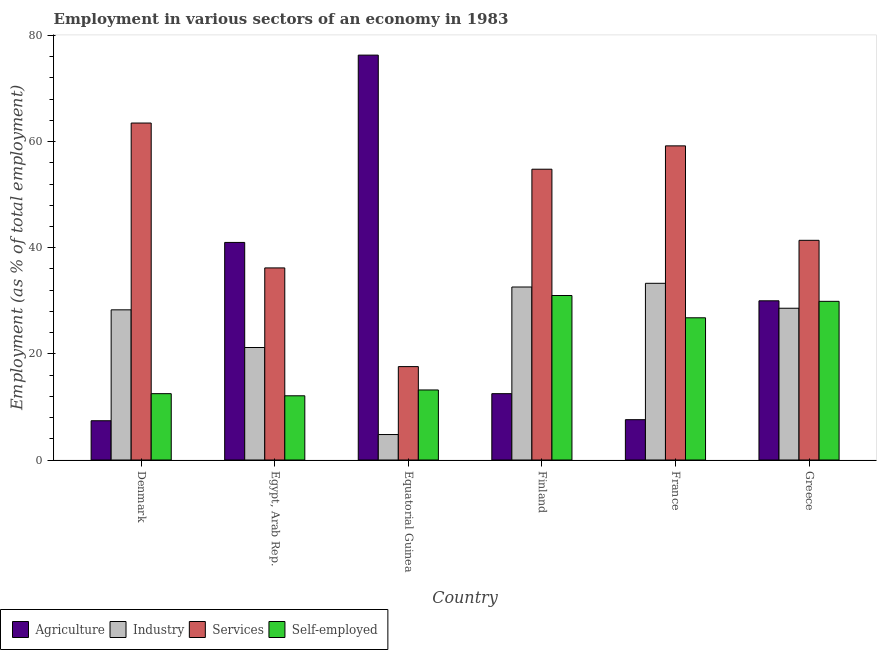Are the number of bars per tick equal to the number of legend labels?
Offer a very short reply. Yes. What is the percentage of workers in industry in France?
Your response must be concise. 33.3. Across all countries, what is the maximum percentage of workers in services?
Keep it short and to the point. 63.5. Across all countries, what is the minimum percentage of workers in services?
Your answer should be very brief. 17.6. In which country was the percentage of workers in services minimum?
Offer a terse response. Equatorial Guinea. What is the total percentage of workers in industry in the graph?
Keep it short and to the point. 148.8. What is the difference between the percentage of workers in agriculture in Equatorial Guinea and that in Greece?
Your answer should be very brief. 46.3. What is the difference between the percentage of workers in industry in Denmark and the percentage of self employed workers in Greece?
Provide a succinct answer. -1.6. What is the average percentage of workers in services per country?
Your answer should be compact. 45.45. What is the difference between the percentage of workers in agriculture and percentage of self employed workers in Equatorial Guinea?
Give a very brief answer. 63.1. What is the ratio of the percentage of workers in services in Denmark to that in Finland?
Your answer should be very brief. 1.16. Is the difference between the percentage of workers in services in Denmark and Finland greater than the difference between the percentage of workers in industry in Denmark and Finland?
Provide a short and direct response. Yes. What is the difference between the highest and the second highest percentage of self employed workers?
Provide a succinct answer. 1.1. What is the difference between the highest and the lowest percentage of workers in agriculture?
Make the answer very short. 68.9. Is it the case that in every country, the sum of the percentage of workers in industry and percentage of workers in agriculture is greater than the sum of percentage of self employed workers and percentage of workers in services?
Make the answer very short. No. What does the 3rd bar from the left in France represents?
Provide a short and direct response. Services. What does the 3rd bar from the right in France represents?
Give a very brief answer. Industry. Is it the case that in every country, the sum of the percentage of workers in agriculture and percentage of workers in industry is greater than the percentage of workers in services?
Keep it short and to the point. No. Are all the bars in the graph horizontal?
Ensure brevity in your answer.  No. Are the values on the major ticks of Y-axis written in scientific E-notation?
Provide a short and direct response. No. Does the graph contain any zero values?
Your answer should be very brief. No. How many legend labels are there?
Ensure brevity in your answer.  4. How are the legend labels stacked?
Provide a succinct answer. Horizontal. What is the title of the graph?
Give a very brief answer. Employment in various sectors of an economy in 1983. Does "Debt policy" appear as one of the legend labels in the graph?
Provide a short and direct response. No. What is the label or title of the Y-axis?
Make the answer very short. Employment (as % of total employment). What is the Employment (as % of total employment) in Agriculture in Denmark?
Provide a succinct answer. 7.4. What is the Employment (as % of total employment) of Industry in Denmark?
Give a very brief answer. 28.3. What is the Employment (as % of total employment) in Services in Denmark?
Make the answer very short. 63.5. What is the Employment (as % of total employment) of Industry in Egypt, Arab Rep.?
Offer a very short reply. 21.2. What is the Employment (as % of total employment) in Services in Egypt, Arab Rep.?
Keep it short and to the point. 36.2. What is the Employment (as % of total employment) of Self-employed in Egypt, Arab Rep.?
Make the answer very short. 12.1. What is the Employment (as % of total employment) of Agriculture in Equatorial Guinea?
Give a very brief answer. 76.3. What is the Employment (as % of total employment) of Industry in Equatorial Guinea?
Make the answer very short. 4.8. What is the Employment (as % of total employment) in Services in Equatorial Guinea?
Your response must be concise. 17.6. What is the Employment (as % of total employment) in Self-employed in Equatorial Guinea?
Offer a very short reply. 13.2. What is the Employment (as % of total employment) of Agriculture in Finland?
Your answer should be compact. 12.5. What is the Employment (as % of total employment) of Industry in Finland?
Your response must be concise. 32.6. What is the Employment (as % of total employment) in Services in Finland?
Your answer should be compact. 54.8. What is the Employment (as % of total employment) of Agriculture in France?
Your answer should be very brief. 7.6. What is the Employment (as % of total employment) of Industry in France?
Provide a short and direct response. 33.3. What is the Employment (as % of total employment) of Services in France?
Provide a short and direct response. 59.2. What is the Employment (as % of total employment) in Self-employed in France?
Offer a very short reply. 26.8. What is the Employment (as % of total employment) of Industry in Greece?
Offer a very short reply. 28.6. What is the Employment (as % of total employment) of Services in Greece?
Provide a succinct answer. 41.4. What is the Employment (as % of total employment) of Self-employed in Greece?
Offer a terse response. 29.9. Across all countries, what is the maximum Employment (as % of total employment) in Agriculture?
Offer a very short reply. 76.3. Across all countries, what is the maximum Employment (as % of total employment) of Industry?
Ensure brevity in your answer.  33.3. Across all countries, what is the maximum Employment (as % of total employment) in Services?
Provide a short and direct response. 63.5. Across all countries, what is the maximum Employment (as % of total employment) in Self-employed?
Ensure brevity in your answer.  31. Across all countries, what is the minimum Employment (as % of total employment) in Agriculture?
Offer a terse response. 7.4. Across all countries, what is the minimum Employment (as % of total employment) of Industry?
Provide a succinct answer. 4.8. Across all countries, what is the minimum Employment (as % of total employment) of Services?
Provide a succinct answer. 17.6. Across all countries, what is the minimum Employment (as % of total employment) of Self-employed?
Your answer should be very brief. 12.1. What is the total Employment (as % of total employment) in Agriculture in the graph?
Provide a short and direct response. 174.8. What is the total Employment (as % of total employment) in Industry in the graph?
Keep it short and to the point. 148.8. What is the total Employment (as % of total employment) in Services in the graph?
Provide a short and direct response. 272.7. What is the total Employment (as % of total employment) in Self-employed in the graph?
Offer a terse response. 125.5. What is the difference between the Employment (as % of total employment) of Agriculture in Denmark and that in Egypt, Arab Rep.?
Your answer should be very brief. -33.6. What is the difference between the Employment (as % of total employment) in Services in Denmark and that in Egypt, Arab Rep.?
Provide a short and direct response. 27.3. What is the difference between the Employment (as % of total employment) in Agriculture in Denmark and that in Equatorial Guinea?
Provide a short and direct response. -68.9. What is the difference between the Employment (as % of total employment) in Industry in Denmark and that in Equatorial Guinea?
Your response must be concise. 23.5. What is the difference between the Employment (as % of total employment) of Services in Denmark and that in Equatorial Guinea?
Make the answer very short. 45.9. What is the difference between the Employment (as % of total employment) of Self-employed in Denmark and that in Finland?
Make the answer very short. -18.5. What is the difference between the Employment (as % of total employment) in Agriculture in Denmark and that in France?
Provide a short and direct response. -0.2. What is the difference between the Employment (as % of total employment) of Self-employed in Denmark and that in France?
Offer a very short reply. -14.3. What is the difference between the Employment (as % of total employment) in Agriculture in Denmark and that in Greece?
Provide a short and direct response. -22.6. What is the difference between the Employment (as % of total employment) of Services in Denmark and that in Greece?
Your response must be concise. 22.1. What is the difference between the Employment (as % of total employment) of Self-employed in Denmark and that in Greece?
Your answer should be very brief. -17.4. What is the difference between the Employment (as % of total employment) of Agriculture in Egypt, Arab Rep. and that in Equatorial Guinea?
Keep it short and to the point. -35.3. What is the difference between the Employment (as % of total employment) of Industry in Egypt, Arab Rep. and that in Equatorial Guinea?
Offer a terse response. 16.4. What is the difference between the Employment (as % of total employment) in Services in Egypt, Arab Rep. and that in Equatorial Guinea?
Your response must be concise. 18.6. What is the difference between the Employment (as % of total employment) in Self-employed in Egypt, Arab Rep. and that in Equatorial Guinea?
Give a very brief answer. -1.1. What is the difference between the Employment (as % of total employment) of Industry in Egypt, Arab Rep. and that in Finland?
Give a very brief answer. -11.4. What is the difference between the Employment (as % of total employment) of Services in Egypt, Arab Rep. and that in Finland?
Make the answer very short. -18.6. What is the difference between the Employment (as % of total employment) of Self-employed in Egypt, Arab Rep. and that in Finland?
Offer a very short reply. -18.9. What is the difference between the Employment (as % of total employment) of Agriculture in Egypt, Arab Rep. and that in France?
Provide a succinct answer. 33.4. What is the difference between the Employment (as % of total employment) in Services in Egypt, Arab Rep. and that in France?
Give a very brief answer. -23. What is the difference between the Employment (as % of total employment) in Self-employed in Egypt, Arab Rep. and that in France?
Give a very brief answer. -14.7. What is the difference between the Employment (as % of total employment) in Services in Egypt, Arab Rep. and that in Greece?
Your answer should be very brief. -5.2. What is the difference between the Employment (as % of total employment) of Self-employed in Egypt, Arab Rep. and that in Greece?
Make the answer very short. -17.8. What is the difference between the Employment (as % of total employment) of Agriculture in Equatorial Guinea and that in Finland?
Make the answer very short. 63.8. What is the difference between the Employment (as % of total employment) in Industry in Equatorial Guinea and that in Finland?
Your response must be concise. -27.8. What is the difference between the Employment (as % of total employment) of Services in Equatorial Guinea and that in Finland?
Provide a short and direct response. -37.2. What is the difference between the Employment (as % of total employment) in Self-employed in Equatorial Guinea and that in Finland?
Make the answer very short. -17.8. What is the difference between the Employment (as % of total employment) of Agriculture in Equatorial Guinea and that in France?
Your answer should be very brief. 68.7. What is the difference between the Employment (as % of total employment) in Industry in Equatorial Guinea and that in France?
Offer a very short reply. -28.5. What is the difference between the Employment (as % of total employment) of Services in Equatorial Guinea and that in France?
Your response must be concise. -41.6. What is the difference between the Employment (as % of total employment) in Agriculture in Equatorial Guinea and that in Greece?
Your answer should be very brief. 46.3. What is the difference between the Employment (as % of total employment) of Industry in Equatorial Guinea and that in Greece?
Your response must be concise. -23.8. What is the difference between the Employment (as % of total employment) of Services in Equatorial Guinea and that in Greece?
Your answer should be very brief. -23.8. What is the difference between the Employment (as % of total employment) of Self-employed in Equatorial Guinea and that in Greece?
Offer a very short reply. -16.7. What is the difference between the Employment (as % of total employment) of Industry in Finland and that in France?
Offer a very short reply. -0.7. What is the difference between the Employment (as % of total employment) of Agriculture in Finland and that in Greece?
Provide a short and direct response. -17.5. What is the difference between the Employment (as % of total employment) in Agriculture in France and that in Greece?
Offer a terse response. -22.4. What is the difference between the Employment (as % of total employment) in Services in France and that in Greece?
Provide a succinct answer. 17.8. What is the difference between the Employment (as % of total employment) in Self-employed in France and that in Greece?
Make the answer very short. -3.1. What is the difference between the Employment (as % of total employment) of Agriculture in Denmark and the Employment (as % of total employment) of Services in Egypt, Arab Rep.?
Give a very brief answer. -28.8. What is the difference between the Employment (as % of total employment) in Industry in Denmark and the Employment (as % of total employment) in Services in Egypt, Arab Rep.?
Your answer should be compact. -7.9. What is the difference between the Employment (as % of total employment) in Services in Denmark and the Employment (as % of total employment) in Self-employed in Egypt, Arab Rep.?
Keep it short and to the point. 51.4. What is the difference between the Employment (as % of total employment) in Agriculture in Denmark and the Employment (as % of total employment) in Industry in Equatorial Guinea?
Provide a short and direct response. 2.6. What is the difference between the Employment (as % of total employment) of Agriculture in Denmark and the Employment (as % of total employment) of Services in Equatorial Guinea?
Provide a short and direct response. -10.2. What is the difference between the Employment (as % of total employment) in Industry in Denmark and the Employment (as % of total employment) in Self-employed in Equatorial Guinea?
Offer a very short reply. 15.1. What is the difference between the Employment (as % of total employment) in Services in Denmark and the Employment (as % of total employment) in Self-employed in Equatorial Guinea?
Provide a short and direct response. 50.3. What is the difference between the Employment (as % of total employment) of Agriculture in Denmark and the Employment (as % of total employment) of Industry in Finland?
Provide a short and direct response. -25.2. What is the difference between the Employment (as % of total employment) in Agriculture in Denmark and the Employment (as % of total employment) in Services in Finland?
Offer a terse response. -47.4. What is the difference between the Employment (as % of total employment) of Agriculture in Denmark and the Employment (as % of total employment) of Self-employed in Finland?
Offer a very short reply. -23.6. What is the difference between the Employment (as % of total employment) in Industry in Denmark and the Employment (as % of total employment) in Services in Finland?
Offer a terse response. -26.5. What is the difference between the Employment (as % of total employment) in Services in Denmark and the Employment (as % of total employment) in Self-employed in Finland?
Provide a short and direct response. 32.5. What is the difference between the Employment (as % of total employment) of Agriculture in Denmark and the Employment (as % of total employment) of Industry in France?
Your answer should be very brief. -25.9. What is the difference between the Employment (as % of total employment) of Agriculture in Denmark and the Employment (as % of total employment) of Services in France?
Provide a short and direct response. -51.8. What is the difference between the Employment (as % of total employment) in Agriculture in Denmark and the Employment (as % of total employment) in Self-employed in France?
Keep it short and to the point. -19.4. What is the difference between the Employment (as % of total employment) in Industry in Denmark and the Employment (as % of total employment) in Services in France?
Make the answer very short. -30.9. What is the difference between the Employment (as % of total employment) of Services in Denmark and the Employment (as % of total employment) of Self-employed in France?
Your answer should be compact. 36.7. What is the difference between the Employment (as % of total employment) in Agriculture in Denmark and the Employment (as % of total employment) in Industry in Greece?
Your answer should be compact. -21.2. What is the difference between the Employment (as % of total employment) of Agriculture in Denmark and the Employment (as % of total employment) of Services in Greece?
Ensure brevity in your answer.  -34. What is the difference between the Employment (as % of total employment) of Agriculture in Denmark and the Employment (as % of total employment) of Self-employed in Greece?
Your answer should be compact. -22.5. What is the difference between the Employment (as % of total employment) in Services in Denmark and the Employment (as % of total employment) in Self-employed in Greece?
Your response must be concise. 33.6. What is the difference between the Employment (as % of total employment) in Agriculture in Egypt, Arab Rep. and the Employment (as % of total employment) in Industry in Equatorial Guinea?
Give a very brief answer. 36.2. What is the difference between the Employment (as % of total employment) in Agriculture in Egypt, Arab Rep. and the Employment (as % of total employment) in Services in Equatorial Guinea?
Provide a succinct answer. 23.4. What is the difference between the Employment (as % of total employment) in Agriculture in Egypt, Arab Rep. and the Employment (as % of total employment) in Self-employed in Equatorial Guinea?
Offer a very short reply. 27.8. What is the difference between the Employment (as % of total employment) in Industry in Egypt, Arab Rep. and the Employment (as % of total employment) in Self-employed in Equatorial Guinea?
Provide a succinct answer. 8. What is the difference between the Employment (as % of total employment) in Agriculture in Egypt, Arab Rep. and the Employment (as % of total employment) in Services in Finland?
Make the answer very short. -13.8. What is the difference between the Employment (as % of total employment) in Agriculture in Egypt, Arab Rep. and the Employment (as % of total employment) in Self-employed in Finland?
Provide a succinct answer. 10. What is the difference between the Employment (as % of total employment) in Industry in Egypt, Arab Rep. and the Employment (as % of total employment) in Services in Finland?
Keep it short and to the point. -33.6. What is the difference between the Employment (as % of total employment) in Agriculture in Egypt, Arab Rep. and the Employment (as % of total employment) in Services in France?
Provide a succinct answer. -18.2. What is the difference between the Employment (as % of total employment) in Agriculture in Egypt, Arab Rep. and the Employment (as % of total employment) in Self-employed in France?
Your response must be concise. 14.2. What is the difference between the Employment (as % of total employment) in Industry in Egypt, Arab Rep. and the Employment (as % of total employment) in Services in France?
Provide a succinct answer. -38. What is the difference between the Employment (as % of total employment) in Industry in Egypt, Arab Rep. and the Employment (as % of total employment) in Self-employed in France?
Give a very brief answer. -5.6. What is the difference between the Employment (as % of total employment) of Services in Egypt, Arab Rep. and the Employment (as % of total employment) of Self-employed in France?
Make the answer very short. 9.4. What is the difference between the Employment (as % of total employment) in Agriculture in Egypt, Arab Rep. and the Employment (as % of total employment) in Industry in Greece?
Provide a succinct answer. 12.4. What is the difference between the Employment (as % of total employment) in Agriculture in Egypt, Arab Rep. and the Employment (as % of total employment) in Services in Greece?
Make the answer very short. -0.4. What is the difference between the Employment (as % of total employment) in Industry in Egypt, Arab Rep. and the Employment (as % of total employment) in Services in Greece?
Provide a short and direct response. -20.2. What is the difference between the Employment (as % of total employment) of Industry in Egypt, Arab Rep. and the Employment (as % of total employment) of Self-employed in Greece?
Keep it short and to the point. -8.7. What is the difference between the Employment (as % of total employment) in Agriculture in Equatorial Guinea and the Employment (as % of total employment) in Industry in Finland?
Your answer should be compact. 43.7. What is the difference between the Employment (as % of total employment) of Agriculture in Equatorial Guinea and the Employment (as % of total employment) of Self-employed in Finland?
Offer a terse response. 45.3. What is the difference between the Employment (as % of total employment) of Industry in Equatorial Guinea and the Employment (as % of total employment) of Services in Finland?
Keep it short and to the point. -50. What is the difference between the Employment (as % of total employment) in Industry in Equatorial Guinea and the Employment (as % of total employment) in Self-employed in Finland?
Provide a short and direct response. -26.2. What is the difference between the Employment (as % of total employment) in Agriculture in Equatorial Guinea and the Employment (as % of total employment) in Services in France?
Your response must be concise. 17.1. What is the difference between the Employment (as % of total employment) of Agriculture in Equatorial Guinea and the Employment (as % of total employment) of Self-employed in France?
Offer a very short reply. 49.5. What is the difference between the Employment (as % of total employment) in Industry in Equatorial Guinea and the Employment (as % of total employment) in Services in France?
Make the answer very short. -54.4. What is the difference between the Employment (as % of total employment) of Industry in Equatorial Guinea and the Employment (as % of total employment) of Self-employed in France?
Provide a short and direct response. -22. What is the difference between the Employment (as % of total employment) of Services in Equatorial Guinea and the Employment (as % of total employment) of Self-employed in France?
Offer a terse response. -9.2. What is the difference between the Employment (as % of total employment) of Agriculture in Equatorial Guinea and the Employment (as % of total employment) of Industry in Greece?
Provide a succinct answer. 47.7. What is the difference between the Employment (as % of total employment) of Agriculture in Equatorial Guinea and the Employment (as % of total employment) of Services in Greece?
Provide a short and direct response. 34.9. What is the difference between the Employment (as % of total employment) of Agriculture in Equatorial Guinea and the Employment (as % of total employment) of Self-employed in Greece?
Provide a succinct answer. 46.4. What is the difference between the Employment (as % of total employment) in Industry in Equatorial Guinea and the Employment (as % of total employment) in Services in Greece?
Ensure brevity in your answer.  -36.6. What is the difference between the Employment (as % of total employment) in Industry in Equatorial Guinea and the Employment (as % of total employment) in Self-employed in Greece?
Ensure brevity in your answer.  -25.1. What is the difference between the Employment (as % of total employment) of Agriculture in Finland and the Employment (as % of total employment) of Industry in France?
Your answer should be very brief. -20.8. What is the difference between the Employment (as % of total employment) in Agriculture in Finland and the Employment (as % of total employment) in Services in France?
Offer a very short reply. -46.7. What is the difference between the Employment (as % of total employment) in Agriculture in Finland and the Employment (as % of total employment) in Self-employed in France?
Give a very brief answer. -14.3. What is the difference between the Employment (as % of total employment) in Industry in Finland and the Employment (as % of total employment) in Services in France?
Give a very brief answer. -26.6. What is the difference between the Employment (as % of total employment) of Industry in Finland and the Employment (as % of total employment) of Self-employed in France?
Give a very brief answer. 5.8. What is the difference between the Employment (as % of total employment) in Agriculture in Finland and the Employment (as % of total employment) in Industry in Greece?
Your answer should be compact. -16.1. What is the difference between the Employment (as % of total employment) in Agriculture in Finland and the Employment (as % of total employment) in Services in Greece?
Your answer should be very brief. -28.9. What is the difference between the Employment (as % of total employment) of Agriculture in Finland and the Employment (as % of total employment) of Self-employed in Greece?
Your response must be concise. -17.4. What is the difference between the Employment (as % of total employment) of Industry in Finland and the Employment (as % of total employment) of Services in Greece?
Provide a succinct answer. -8.8. What is the difference between the Employment (as % of total employment) in Industry in Finland and the Employment (as % of total employment) in Self-employed in Greece?
Your answer should be compact. 2.7. What is the difference between the Employment (as % of total employment) of Services in Finland and the Employment (as % of total employment) of Self-employed in Greece?
Your response must be concise. 24.9. What is the difference between the Employment (as % of total employment) in Agriculture in France and the Employment (as % of total employment) in Services in Greece?
Your answer should be compact. -33.8. What is the difference between the Employment (as % of total employment) of Agriculture in France and the Employment (as % of total employment) of Self-employed in Greece?
Ensure brevity in your answer.  -22.3. What is the difference between the Employment (as % of total employment) of Industry in France and the Employment (as % of total employment) of Services in Greece?
Offer a terse response. -8.1. What is the difference between the Employment (as % of total employment) in Services in France and the Employment (as % of total employment) in Self-employed in Greece?
Keep it short and to the point. 29.3. What is the average Employment (as % of total employment) in Agriculture per country?
Your answer should be compact. 29.13. What is the average Employment (as % of total employment) in Industry per country?
Give a very brief answer. 24.8. What is the average Employment (as % of total employment) in Services per country?
Offer a very short reply. 45.45. What is the average Employment (as % of total employment) in Self-employed per country?
Provide a succinct answer. 20.92. What is the difference between the Employment (as % of total employment) of Agriculture and Employment (as % of total employment) of Industry in Denmark?
Your response must be concise. -20.9. What is the difference between the Employment (as % of total employment) in Agriculture and Employment (as % of total employment) in Services in Denmark?
Keep it short and to the point. -56.1. What is the difference between the Employment (as % of total employment) in Agriculture and Employment (as % of total employment) in Self-employed in Denmark?
Offer a terse response. -5.1. What is the difference between the Employment (as % of total employment) in Industry and Employment (as % of total employment) in Services in Denmark?
Offer a very short reply. -35.2. What is the difference between the Employment (as % of total employment) in Industry and Employment (as % of total employment) in Self-employed in Denmark?
Your answer should be very brief. 15.8. What is the difference between the Employment (as % of total employment) in Services and Employment (as % of total employment) in Self-employed in Denmark?
Provide a succinct answer. 51. What is the difference between the Employment (as % of total employment) in Agriculture and Employment (as % of total employment) in Industry in Egypt, Arab Rep.?
Provide a succinct answer. 19.8. What is the difference between the Employment (as % of total employment) in Agriculture and Employment (as % of total employment) in Services in Egypt, Arab Rep.?
Ensure brevity in your answer.  4.8. What is the difference between the Employment (as % of total employment) in Agriculture and Employment (as % of total employment) in Self-employed in Egypt, Arab Rep.?
Make the answer very short. 28.9. What is the difference between the Employment (as % of total employment) of Industry and Employment (as % of total employment) of Services in Egypt, Arab Rep.?
Give a very brief answer. -15. What is the difference between the Employment (as % of total employment) in Industry and Employment (as % of total employment) in Self-employed in Egypt, Arab Rep.?
Keep it short and to the point. 9.1. What is the difference between the Employment (as % of total employment) in Services and Employment (as % of total employment) in Self-employed in Egypt, Arab Rep.?
Ensure brevity in your answer.  24.1. What is the difference between the Employment (as % of total employment) of Agriculture and Employment (as % of total employment) of Industry in Equatorial Guinea?
Offer a terse response. 71.5. What is the difference between the Employment (as % of total employment) of Agriculture and Employment (as % of total employment) of Services in Equatorial Guinea?
Keep it short and to the point. 58.7. What is the difference between the Employment (as % of total employment) in Agriculture and Employment (as % of total employment) in Self-employed in Equatorial Guinea?
Offer a very short reply. 63.1. What is the difference between the Employment (as % of total employment) of Industry and Employment (as % of total employment) of Self-employed in Equatorial Guinea?
Ensure brevity in your answer.  -8.4. What is the difference between the Employment (as % of total employment) of Agriculture and Employment (as % of total employment) of Industry in Finland?
Your response must be concise. -20.1. What is the difference between the Employment (as % of total employment) in Agriculture and Employment (as % of total employment) in Services in Finland?
Provide a succinct answer. -42.3. What is the difference between the Employment (as % of total employment) of Agriculture and Employment (as % of total employment) of Self-employed in Finland?
Give a very brief answer. -18.5. What is the difference between the Employment (as % of total employment) in Industry and Employment (as % of total employment) in Services in Finland?
Keep it short and to the point. -22.2. What is the difference between the Employment (as % of total employment) of Industry and Employment (as % of total employment) of Self-employed in Finland?
Offer a very short reply. 1.6. What is the difference between the Employment (as % of total employment) of Services and Employment (as % of total employment) of Self-employed in Finland?
Give a very brief answer. 23.8. What is the difference between the Employment (as % of total employment) of Agriculture and Employment (as % of total employment) of Industry in France?
Provide a succinct answer. -25.7. What is the difference between the Employment (as % of total employment) in Agriculture and Employment (as % of total employment) in Services in France?
Offer a very short reply. -51.6. What is the difference between the Employment (as % of total employment) in Agriculture and Employment (as % of total employment) in Self-employed in France?
Provide a succinct answer. -19.2. What is the difference between the Employment (as % of total employment) of Industry and Employment (as % of total employment) of Services in France?
Offer a terse response. -25.9. What is the difference between the Employment (as % of total employment) of Services and Employment (as % of total employment) of Self-employed in France?
Offer a terse response. 32.4. What is the difference between the Employment (as % of total employment) of Agriculture and Employment (as % of total employment) of Industry in Greece?
Give a very brief answer. 1.4. What is the difference between the Employment (as % of total employment) in Agriculture and Employment (as % of total employment) in Services in Greece?
Your answer should be compact. -11.4. What is the difference between the Employment (as % of total employment) of Industry and Employment (as % of total employment) of Self-employed in Greece?
Offer a very short reply. -1.3. What is the difference between the Employment (as % of total employment) of Services and Employment (as % of total employment) of Self-employed in Greece?
Keep it short and to the point. 11.5. What is the ratio of the Employment (as % of total employment) in Agriculture in Denmark to that in Egypt, Arab Rep.?
Your answer should be very brief. 0.18. What is the ratio of the Employment (as % of total employment) in Industry in Denmark to that in Egypt, Arab Rep.?
Ensure brevity in your answer.  1.33. What is the ratio of the Employment (as % of total employment) of Services in Denmark to that in Egypt, Arab Rep.?
Provide a succinct answer. 1.75. What is the ratio of the Employment (as % of total employment) in Self-employed in Denmark to that in Egypt, Arab Rep.?
Give a very brief answer. 1.03. What is the ratio of the Employment (as % of total employment) in Agriculture in Denmark to that in Equatorial Guinea?
Make the answer very short. 0.1. What is the ratio of the Employment (as % of total employment) in Industry in Denmark to that in Equatorial Guinea?
Give a very brief answer. 5.9. What is the ratio of the Employment (as % of total employment) in Services in Denmark to that in Equatorial Guinea?
Offer a terse response. 3.61. What is the ratio of the Employment (as % of total employment) in Self-employed in Denmark to that in Equatorial Guinea?
Ensure brevity in your answer.  0.95. What is the ratio of the Employment (as % of total employment) in Agriculture in Denmark to that in Finland?
Your answer should be very brief. 0.59. What is the ratio of the Employment (as % of total employment) in Industry in Denmark to that in Finland?
Offer a very short reply. 0.87. What is the ratio of the Employment (as % of total employment) of Services in Denmark to that in Finland?
Make the answer very short. 1.16. What is the ratio of the Employment (as % of total employment) in Self-employed in Denmark to that in Finland?
Ensure brevity in your answer.  0.4. What is the ratio of the Employment (as % of total employment) in Agriculture in Denmark to that in France?
Your answer should be compact. 0.97. What is the ratio of the Employment (as % of total employment) of Industry in Denmark to that in France?
Your answer should be very brief. 0.85. What is the ratio of the Employment (as % of total employment) in Services in Denmark to that in France?
Give a very brief answer. 1.07. What is the ratio of the Employment (as % of total employment) in Self-employed in Denmark to that in France?
Your answer should be compact. 0.47. What is the ratio of the Employment (as % of total employment) in Agriculture in Denmark to that in Greece?
Keep it short and to the point. 0.25. What is the ratio of the Employment (as % of total employment) in Industry in Denmark to that in Greece?
Ensure brevity in your answer.  0.99. What is the ratio of the Employment (as % of total employment) in Services in Denmark to that in Greece?
Your response must be concise. 1.53. What is the ratio of the Employment (as % of total employment) of Self-employed in Denmark to that in Greece?
Provide a succinct answer. 0.42. What is the ratio of the Employment (as % of total employment) in Agriculture in Egypt, Arab Rep. to that in Equatorial Guinea?
Your answer should be very brief. 0.54. What is the ratio of the Employment (as % of total employment) of Industry in Egypt, Arab Rep. to that in Equatorial Guinea?
Your answer should be very brief. 4.42. What is the ratio of the Employment (as % of total employment) in Services in Egypt, Arab Rep. to that in Equatorial Guinea?
Your answer should be compact. 2.06. What is the ratio of the Employment (as % of total employment) in Agriculture in Egypt, Arab Rep. to that in Finland?
Provide a succinct answer. 3.28. What is the ratio of the Employment (as % of total employment) in Industry in Egypt, Arab Rep. to that in Finland?
Offer a very short reply. 0.65. What is the ratio of the Employment (as % of total employment) in Services in Egypt, Arab Rep. to that in Finland?
Give a very brief answer. 0.66. What is the ratio of the Employment (as % of total employment) of Self-employed in Egypt, Arab Rep. to that in Finland?
Keep it short and to the point. 0.39. What is the ratio of the Employment (as % of total employment) of Agriculture in Egypt, Arab Rep. to that in France?
Your response must be concise. 5.39. What is the ratio of the Employment (as % of total employment) in Industry in Egypt, Arab Rep. to that in France?
Your answer should be compact. 0.64. What is the ratio of the Employment (as % of total employment) in Services in Egypt, Arab Rep. to that in France?
Keep it short and to the point. 0.61. What is the ratio of the Employment (as % of total employment) in Self-employed in Egypt, Arab Rep. to that in France?
Your answer should be compact. 0.45. What is the ratio of the Employment (as % of total employment) of Agriculture in Egypt, Arab Rep. to that in Greece?
Provide a succinct answer. 1.37. What is the ratio of the Employment (as % of total employment) in Industry in Egypt, Arab Rep. to that in Greece?
Your answer should be very brief. 0.74. What is the ratio of the Employment (as % of total employment) in Services in Egypt, Arab Rep. to that in Greece?
Your response must be concise. 0.87. What is the ratio of the Employment (as % of total employment) in Self-employed in Egypt, Arab Rep. to that in Greece?
Provide a short and direct response. 0.4. What is the ratio of the Employment (as % of total employment) of Agriculture in Equatorial Guinea to that in Finland?
Make the answer very short. 6.1. What is the ratio of the Employment (as % of total employment) in Industry in Equatorial Guinea to that in Finland?
Make the answer very short. 0.15. What is the ratio of the Employment (as % of total employment) in Services in Equatorial Guinea to that in Finland?
Your answer should be compact. 0.32. What is the ratio of the Employment (as % of total employment) in Self-employed in Equatorial Guinea to that in Finland?
Offer a terse response. 0.43. What is the ratio of the Employment (as % of total employment) of Agriculture in Equatorial Guinea to that in France?
Give a very brief answer. 10.04. What is the ratio of the Employment (as % of total employment) in Industry in Equatorial Guinea to that in France?
Your answer should be very brief. 0.14. What is the ratio of the Employment (as % of total employment) of Services in Equatorial Guinea to that in France?
Ensure brevity in your answer.  0.3. What is the ratio of the Employment (as % of total employment) of Self-employed in Equatorial Guinea to that in France?
Your answer should be very brief. 0.49. What is the ratio of the Employment (as % of total employment) in Agriculture in Equatorial Guinea to that in Greece?
Provide a short and direct response. 2.54. What is the ratio of the Employment (as % of total employment) in Industry in Equatorial Guinea to that in Greece?
Offer a very short reply. 0.17. What is the ratio of the Employment (as % of total employment) in Services in Equatorial Guinea to that in Greece?
Provide a succinct answer. 0.43. What is the ratio of the Employment (as % of total employment) of Self-employed in Equatorial Guinea to that in Greece?
Offer a terse response. 0.44. What is the ratio of the Employment (as % of total employment) of Agriculture in Finland to that in France?
Your answer should be very brief. 1.64. What is the ratio of the Employment (as % of total employment) of Services in Finland to that in France?
Your response must be concise. 0.93. What is the ratio of the Employment (as % of total employment) in Self-employed in Finland to that in France?
Ensure brevity in your answer.  1.16. What is the ratio of the Employment (as % of total employment) in Agriculture in Finland to that in Greece?
Keep it short and to the point. 0.42. What is the ratio of the Employment (as % of total employment) in Industry in Finland to that in Greece?
Your response must be concise. 1.14. What is the ratio of the Employment (as % of total employment) of Services in Finland to that in Greece?
Provide a succinct answer. 1.32. What is the ratio of the Employment (as % of total employment) in Self-employed in Finland to that in Greece?
Provide a succinct answer. 1.04. What is the ratio of the Employment (as % of total employment) of Agriculture in France to that in Greece?
Give a very brief answer. 0.25. What is the ratio of the Employment (as % of total employment) of Industry in France to that in Greece?
Your answer should be very brief. 1.16. What is the ratio of the Employment (as % of total employment) of Services in France to that in Greece?
Your answer should be very brief. 1.43. What is the ratio of the Employment (as % of total employment) in Self-employed in France to that in Greece?
Ensure brevity in your answer.  0.9. What is the difference between the highest and the second highest Employment (as % of total employment) of Agriculture?
Offer a terse response. 35.3. What is the difference between the highest and the second highest Employment (as % of total employment) in Industry?
Your answer should be compact. 0.7. What is the difference between the highest and the second highest Employment (as % of total employment) of Self-employed?
Make the answer very short. 1.1. What is the difference between the highest and the lowest Employment (as % of total employment) of Agriculture?
Your answer should be very brief. 68.9. What is the difference between the highest and the lowest Employment (as % of total employment) of Industry?
Your answer should be very brief. 28.5. What is the difference between the highest and the lowest Employment (as % of total employment) in Services?
Make the answer very short. 45.9. 